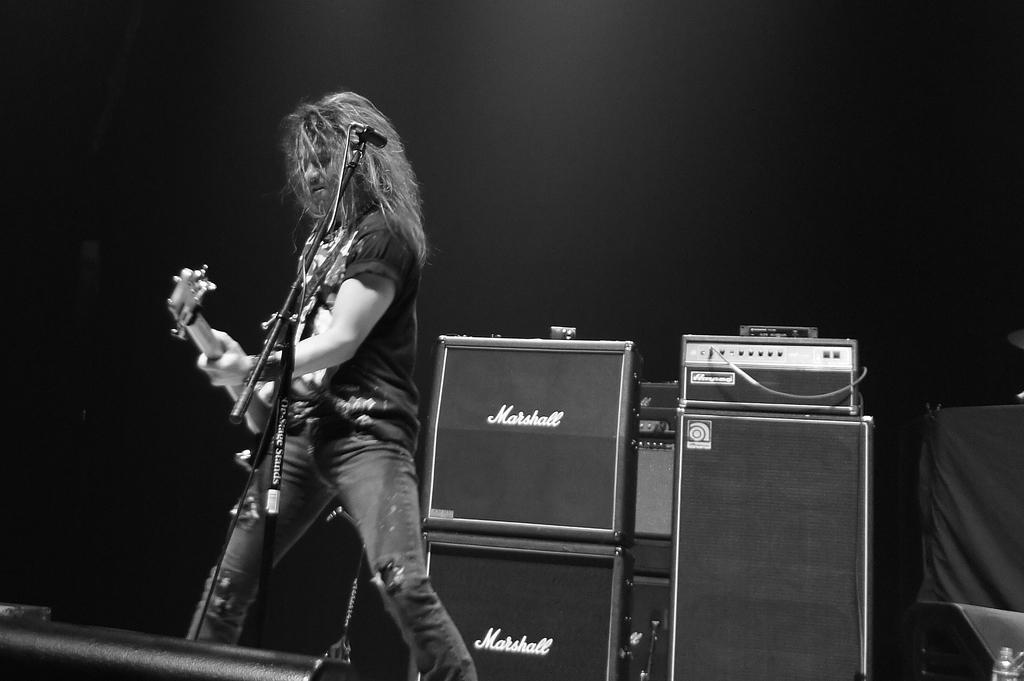<image>
Summarize the visual content of the image. A guitaris plays his instrument in front of some Marshall amps. 